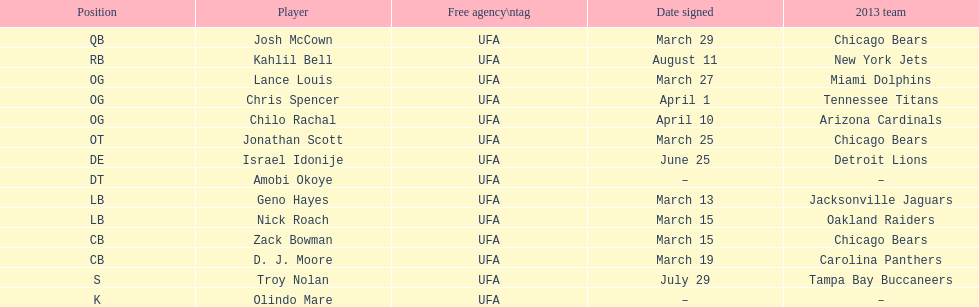Total number of players that signed in march? 7. 